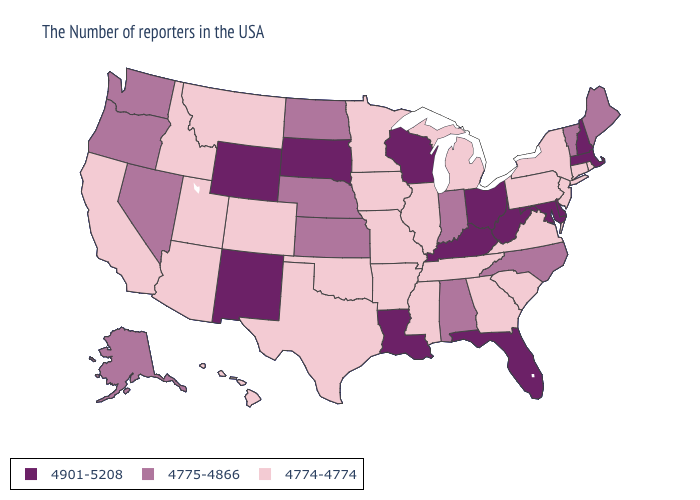Does California have the lowest value in the USA?
Give a very brief answer. Yes. Among the states that border Colorado , which have the lowest value?
Keep it brief. Oklahoma, Utah, Arizona. Does the first symbol in the legend represent the smallest category?
Be succinct. No. What is the highest value in the MidWest ?
Be succinct. 4901-5208. Name the states that have a value in the range 4775-4866?
Short answer required. Maine, Vermont, North Carolina, Indiana, Alabama, Kansas, Nebraska, North Dakota, Nevada, Washington, Oregon, Alaska. Name the states that have a value in the range 4901-5208?
Be succinct. Massachusetts, New Hampshire, Delaware, Maryland, West Virginia, Ohio, Florida, Kentucky, Wisconsin, Louisiana, South Dakota, Wyoming, New Mexico. What is the lowest value in the South?
Concise answer only. 4774-4774. Among the states that border Wyoming , which have the highest value?
Keep it brief. South Dakota. Does Arkansas have the highest value in the USA?
Short answer required. No. Does Washington have the same value as Virginia?
Write a very short answer. No. Name the states that have a value in the range 4774-4774?
Write a very short answer. Rhode Island, Connecticut, New York, New Jersey, Pennsylvania, Virginia, South Carolina, Georgia, Michigan, Tennessee, Illinois, Mississippi, Missouri, Arkansas, Minnesota, Iowa, Oklahoma, Texas, Colorado, Utah, Montana, Arizona, Idaho, California, Hawaii. Name the states that have a value in the range 4775-4866?
Concise answer only. Maine, Vermont, North Carolina, Indiana, Alabama, Kansas, Nebraska, North Dakota, Nevada, Washington, Oregon, Alaska. What is the value of Tennessee?
Keep it brief. 4774-4774. Does North Dakota have the lowest value in the MidWest?
Give a very brief answer. No. 